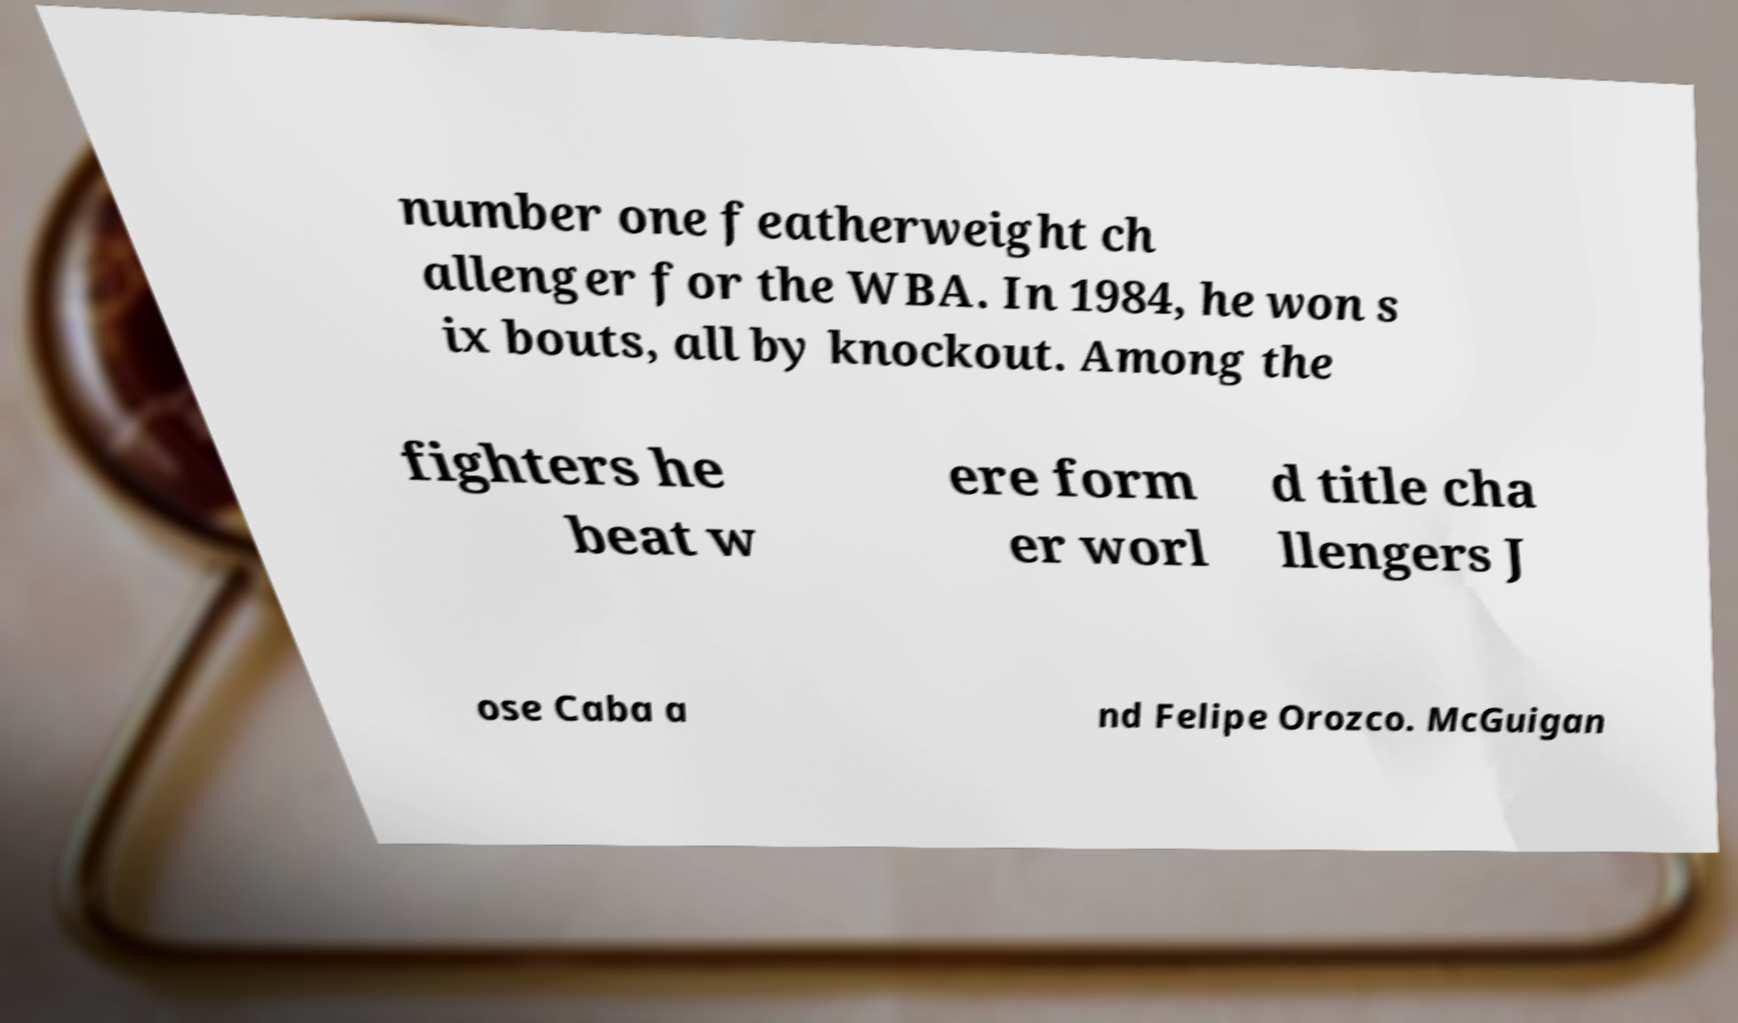There's text embedded in this image that I need extracted. Can you transcribe it verbatim? number one featherweight ch allenger for the WBA. In 1984, he won s ix bouts, all by knockout. Among the fighters he beat w ere form er worl d title cha llengers J ose Caba a nd Felipe Orozco. McGuigan 